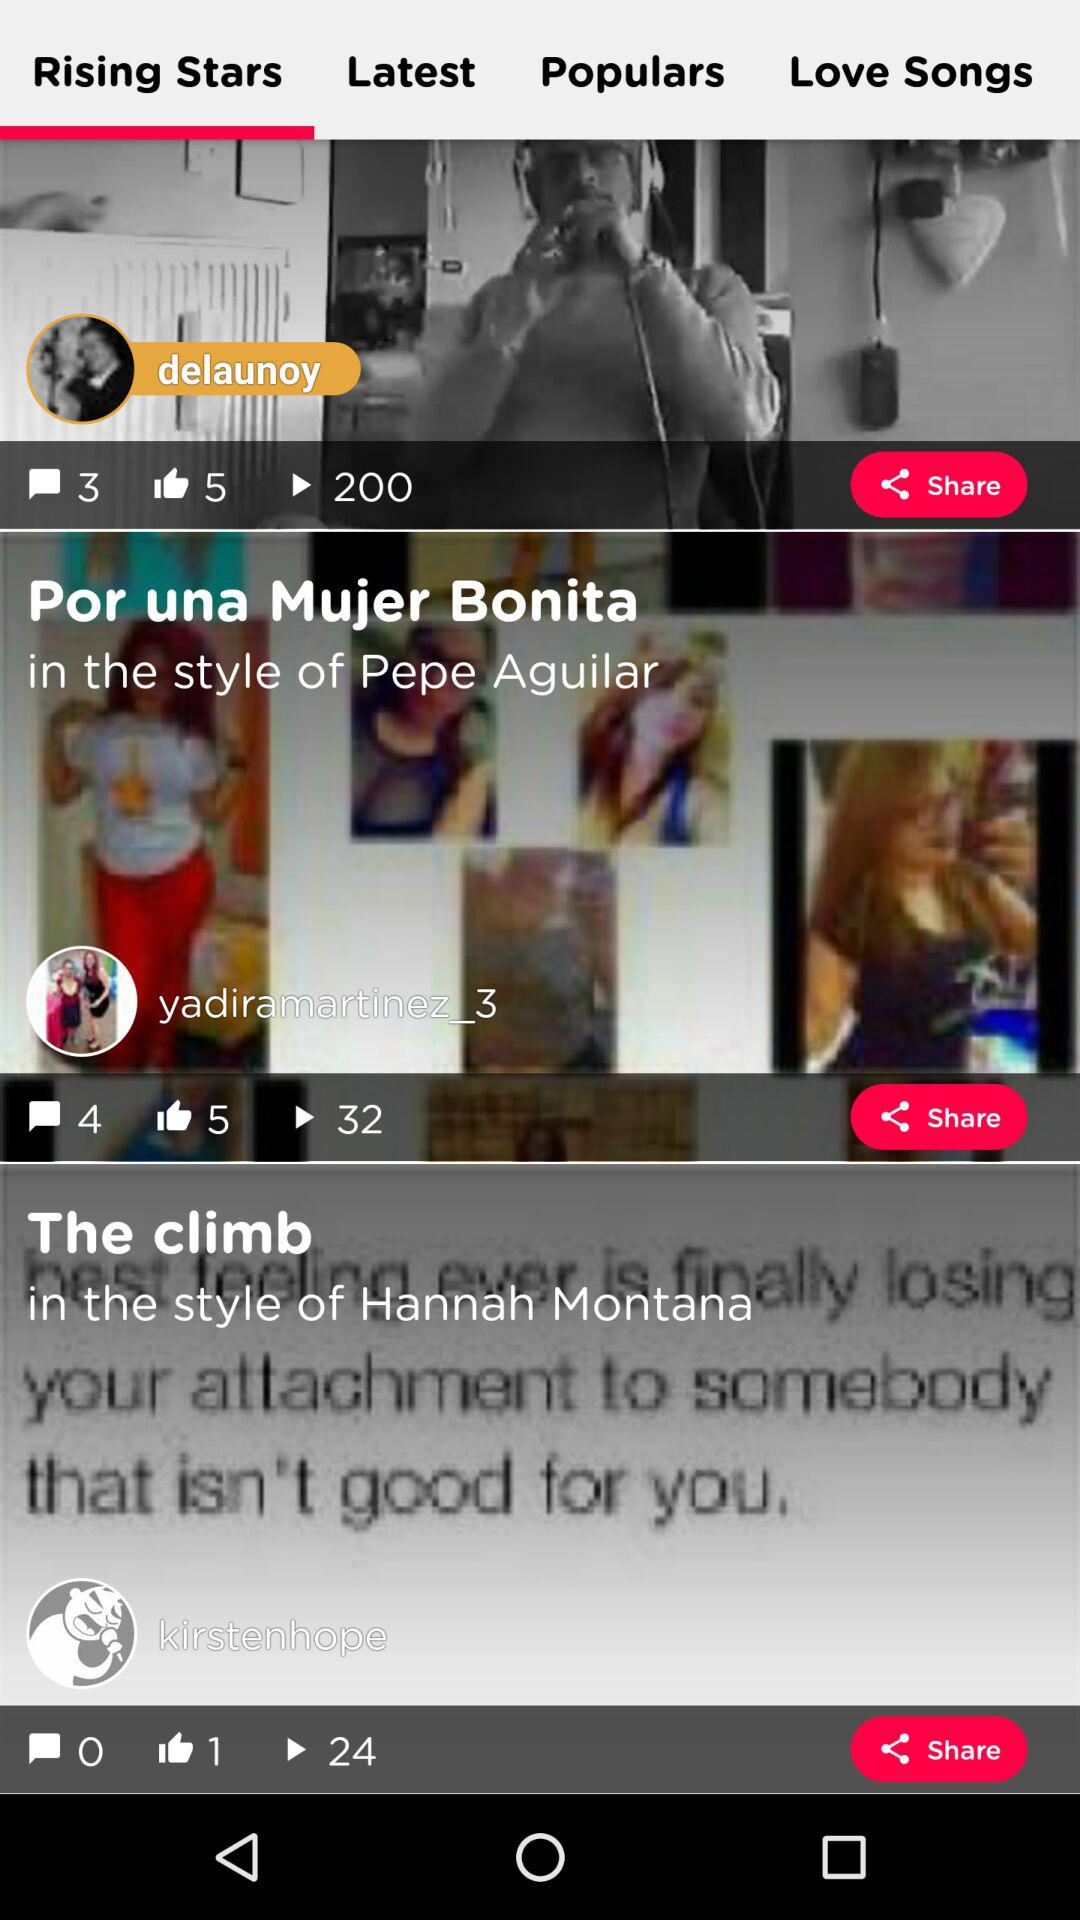What is the number shown in yadiramartinez_3 post?
When the provided information is insufficient, respond with <no answer>. <no answer> 